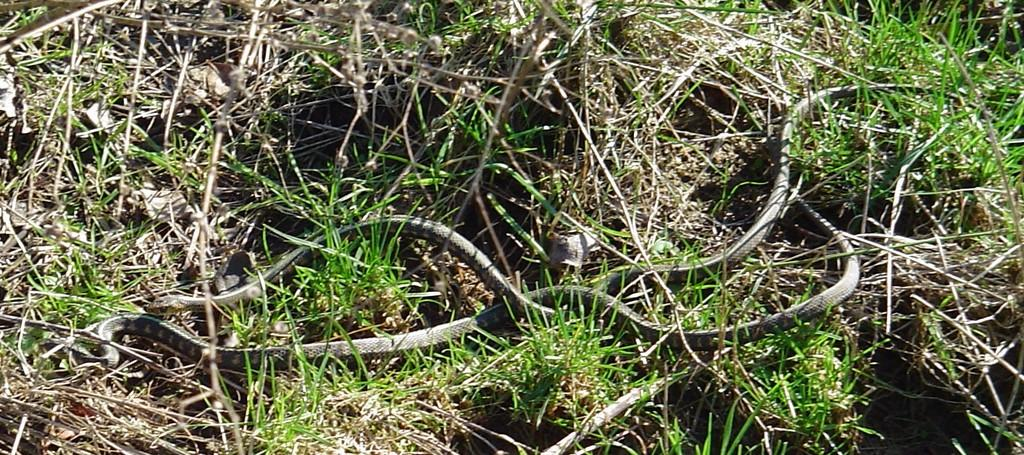What animals are present in the picture? There are two snakes in the picture. Where are the snakes located? The snakes are on the grass. What type of vegetation can be seen in the picture? There is grass visible in the picture. What type of prison can be seen in the background of the image? There is no prison present in the image; it features two snakes on the grass. How far is the edge of the sea from the snakes in the image? There is no sea present in the image, so it is not possible to determine the distance to its edge. 